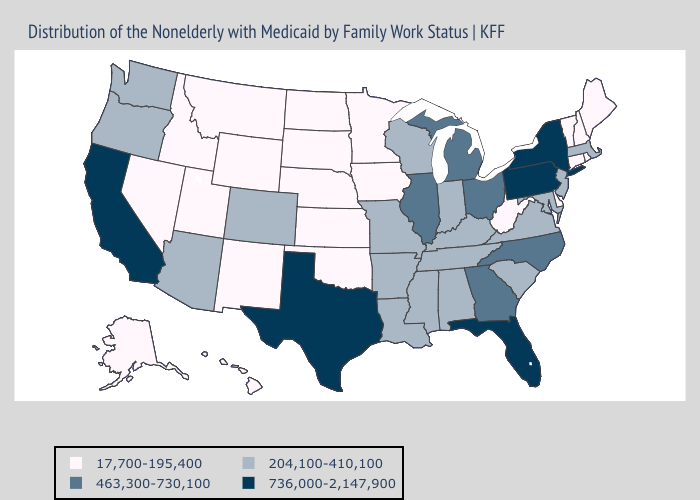What is the lowest value in the Northeast?
Concise answer only. 17,700-195,400. What is the highest value in states that border New Mexico?
Short answer required. 736,000-2,147,900. What is the value of Missouri?
Keep it brief. 204,100-410,100. Does the map have missing data?
Concise answer only. No. What is the lowest value in states that border Nevada?
Short answer required. 17,700-195,400. Name the states that have a value in the range 204,100-410,100?
Be succinct. Alabama, Arizona, Arkansas, Colorado, Indiana, Kentucky, Louisiana, Maryland, Massachusetts, Mississippi, Missouri, New Jersey, Oregon, South Carolina, Tennessee, Virginia, Washington, Wisconsin. What is the value of Colorado?
Answer briefly. 204,100-410,100. Does the map have missing data?
Write a very short answer. No. What is the value of Virginia?
Quick response, please. 204,100-410,100. Does Arkansas have a higher value than Virginia?
Quick response, please. No. What is the value of Michigan?
Give a very brief answer. 463,300-730,100. Which states have the lowest value in the West?
Give a very brief answer. Alaska, Hawaii, Idaho, Montana, Nevada, New Mexico, Utah, Wyoming. Among the states that border Alabama , does Mississippi have the lowest value?
Concise answer only. Yes. Name the states that have a value in the range 17,700-195,400?
Quick response, please. Alaska, Connecticut, Delaware, Hawaii, Idaho, Iowa, Kansas, Maine, Minnesota, Montana, Nebraska, Nevada, New Hampshire, New Mexico, North Dakota, Oklahoma, Rhode Island, South Dakota, Utah, Vermont, West Virginia, Wyoming. Does the map have missing data?
Quick response, please. No. 